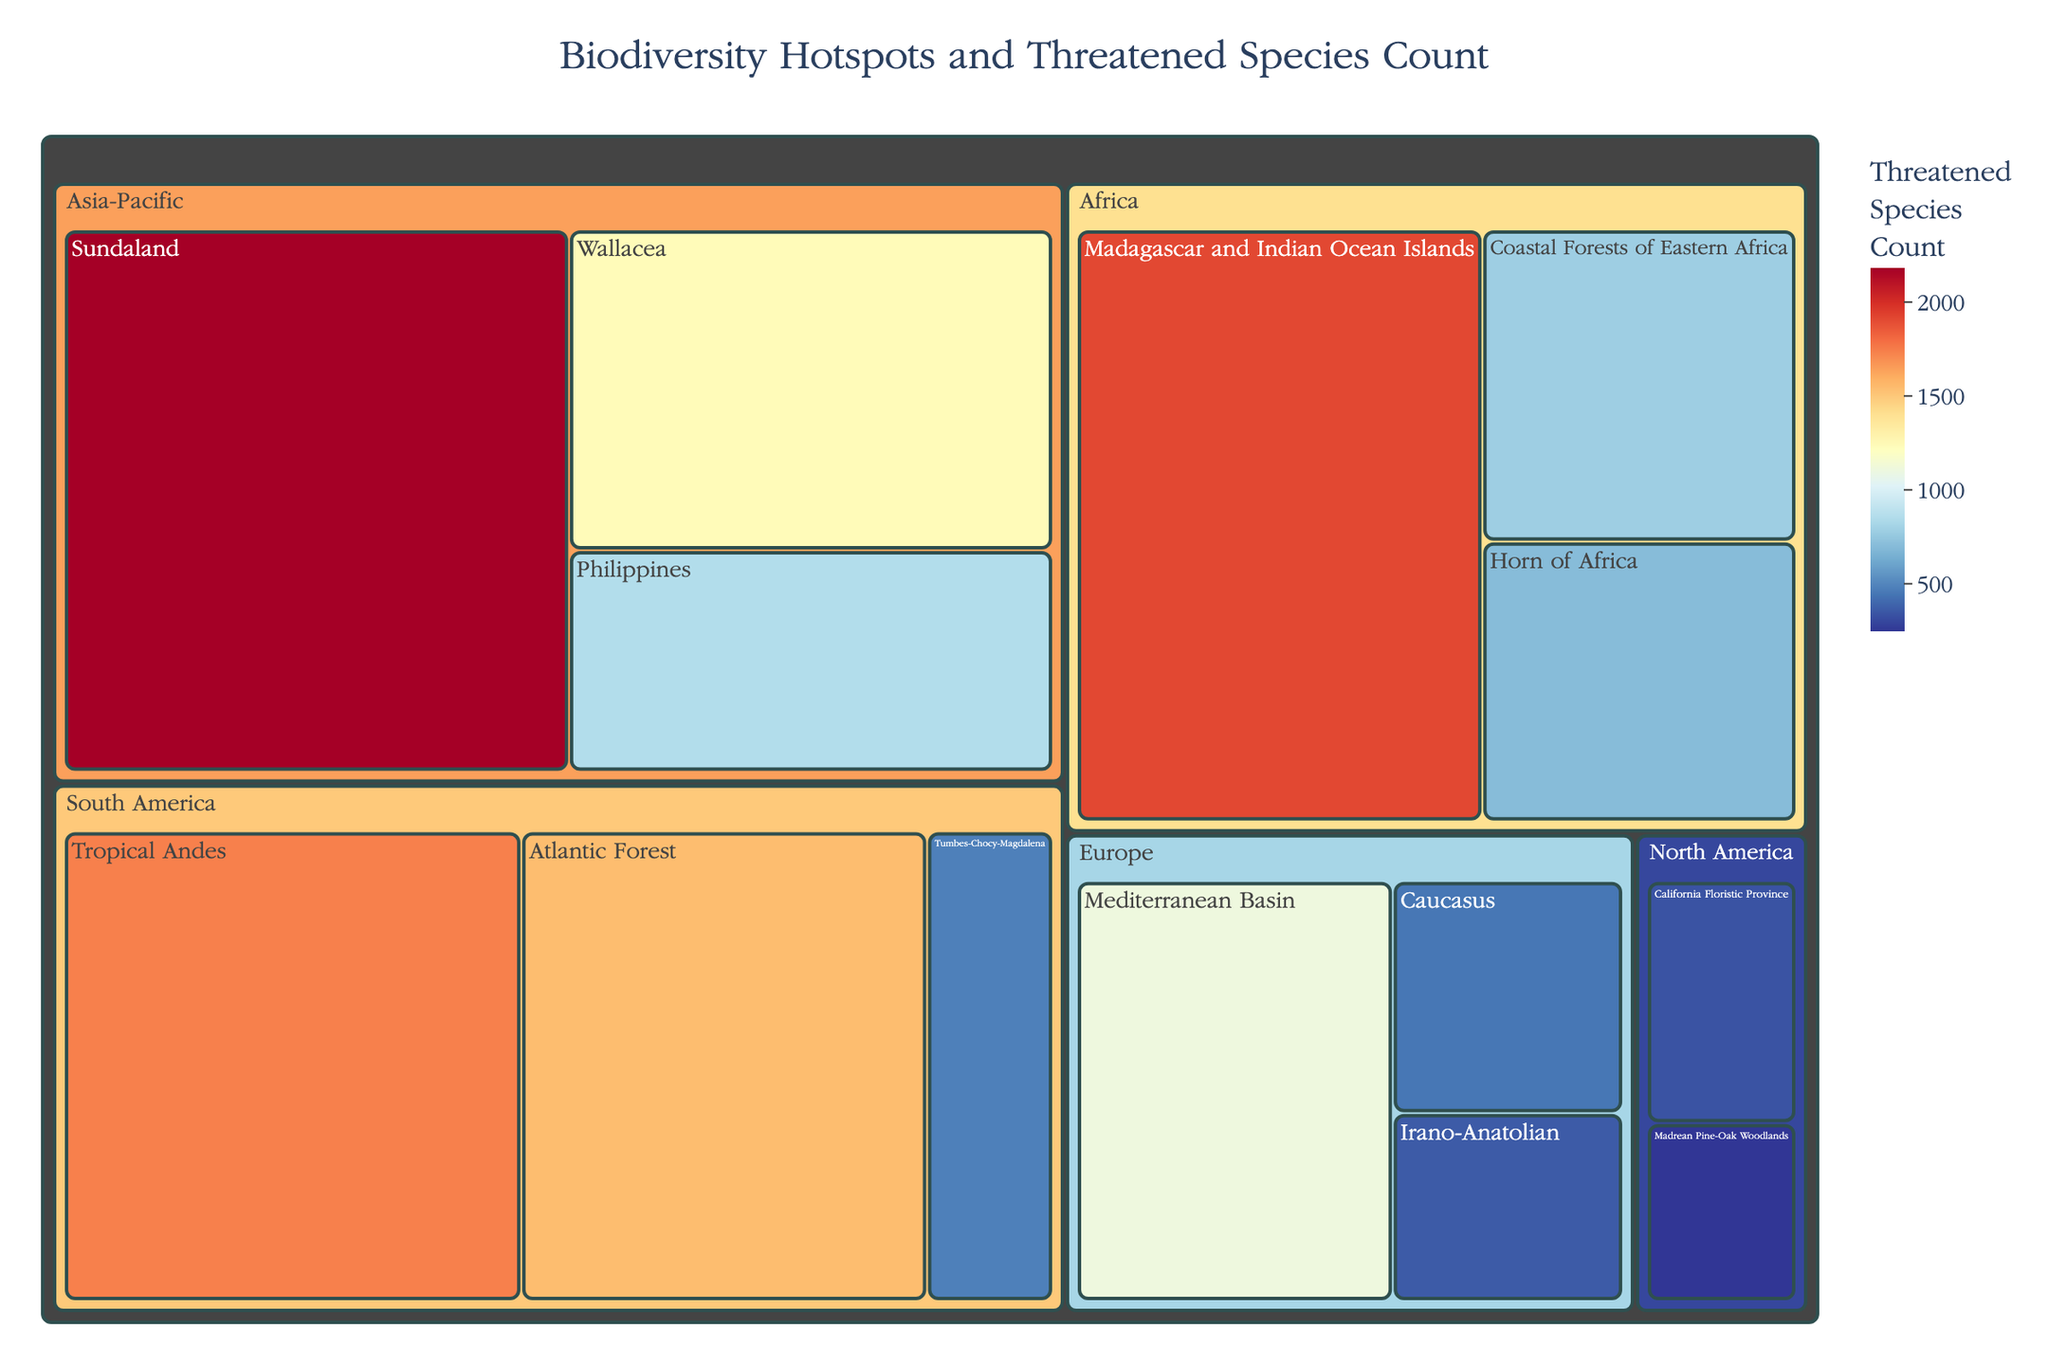What is the title of the treemap? The title is displayed at the top of the treemap.
Answer: Biodiversity Hotspots and Threatened Species Count Which region has the biodiversity hotspot with the highest threatened species count? Observe the color scale and the size of the sections in the treemap, and locate the largest, darkest colored hotspot.
Answer: Asia-Pacific What is the number of threatened species in the Tropical Andes? Hover over or visually locate the "Tropical Andes" section and read or hover over the value showing the threatened species count.
Answer: 1740 Which biodiversity hotspot has a higher threatened species count: the Mediterranean Basin or the Atlantic Forest? Compare the values for these specific hotspots by locating their sections in the treemap.
Answer: Atlantic Forest How many biodiversity hotspots are depicted for Africa? Identify and count the different segments under the Africa region.
Answer: 3 What is the total number of threatened species in the Europe region? Sum the threatened species counts for all hotspots under the Europe region: 1110 (Mediterranean Basin) + 447 (Caucasus) + 362 (Irano-Anatolian).
Answer: 1919 Which region has the smallest biodiversity hotspot by threatened species count, and what is the count? Look for the smallest section (smallest size and lightest color) in the treemap.
Answer: North America, Madrean Pine-Oak Woodlands, 247 How does the threatened species count of the Horn of Africa compare to that of the California Floristic Province? Compare the values within their respective sections in the treemap.
Answer: The Horn of Africa has 701 threatened species, and the California Floristic Province has 336. So, the Horn of Africa has more What is the average number of threatened species in South American biodiversity hotspots? Sum the counts for South American hotspots and divide by the number of hotspots: (1740 + 1544 + 479)/3.
Answer: 1254.33 (1255 if rounded) Which biodiversity hotspot in Asia-Pacific has the lowest count of threatened species? Identify the region Asia-Pacific, then find the hotspot with the smallest value within that region.
Answer: Philippines 